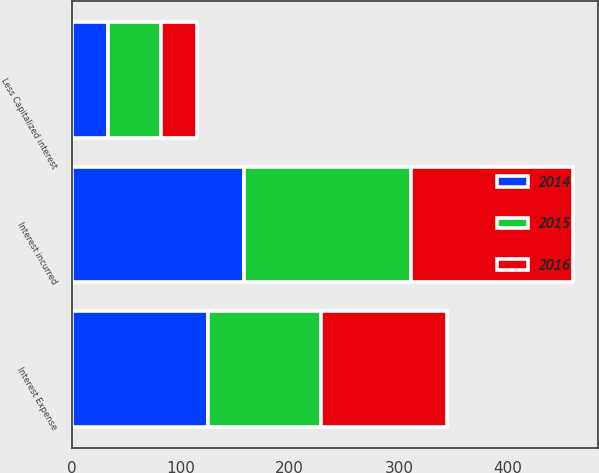Convert chart to OTSL. <chart><loc_0><loc_0><loc_500><loc_500><stacked_bar_chart><ecel><fcel>Interest incurred<fcel>Less Capitalized interest<fcel>Interest Expense<nl><fcel>2016<fcel>148.4<fcel>32.9<fcel>115.5<nl><fcel>2015<fcel>152.6<fcel>49.1<fcel>103.5<nl><fcel>2014<fcel>158.1<fcel>33<fcel>125.1<nl></chart> 